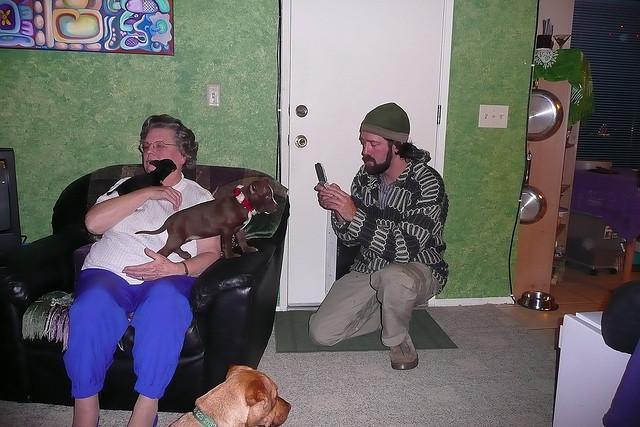How many dogs are in the  picture?
Give a very brief answer. 3. How many pots are on the wall?
Give a very brief answer. 2. How many people are in the picture?
Give a very brief answer. 2. How many dogs are there?
Give a very brief answer. 2. 